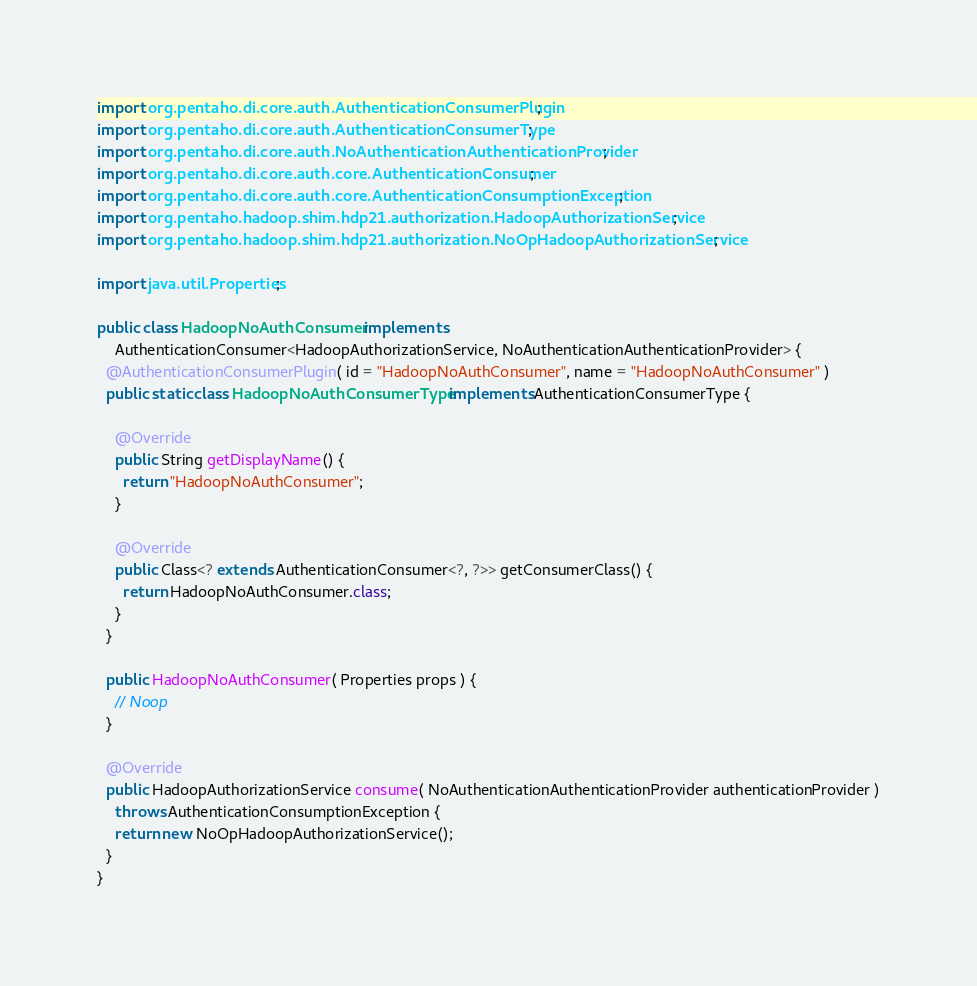Convert code to text. <code><loc_0><loc_0><loc_500><loc_500><_Java_>import org.pentaho.di.core.auth.AuthenticationConsumerPlugin;
import org.pentaho.di.core.auth.AuthenticationConsumerType;
import org.pentaho.di.core.auth.NoAuthenticationAuthenticationProvider;
import org.pentaho.di.core.auth.core.AuthenticationConsumer;
import org.pentaho.di.core.auth.core.AuthenticationConsumptionException;
import org.pentaho.hadoop.shim.hdp21.authorization.HadoopAuthorizationService;
import org.pentaho.hadoop.shim.hdp21.authorization.NoOpHadoopAuthorizationService;

import java.util.Properties;

public class HadoopNoAuthConsumer implements
    AuthenticationConsumer<HadoopAuthorizationService, NoAuthenticationAuthenticationProvider> {
  @AuthenticationConsumerPlugin( id = "HadoopNoAuthConsumer", name = "HadoopNoAuthConsumer" )
  public static class HadoopNoAuthConsumerType implements AuthenticationConsumerType {

    @Override
    public String getDisplayName() {
      return "HadoopNoAuthConsumer";
    }

    @Override
    public Class<? extends AuthenticationConsumer<?, ?>> getConsumerClass() {
      return HadoopNoAuthConsumer.class;
    }
  }

  public HadoopNoAuthConsumer( Properties props ) {
    // Noop
  }

  @Override
  public HadoopAuthorizationService consume( NoAuthenticationAuthenticationProvider authenticationProvider )
    throws AuthenticationConsumptionException {
    return new NoOpHadoopAuthorizationService();
  }
}
</code> 